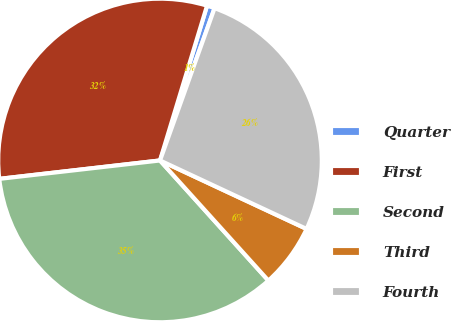Convert chart to OTSL. <chart><loc_0><loc_0><loc_500><loc_500><pie_chart><fcel>Quarter<fcel>First<fcel>Second<fcel>Third<fcel>Fourth<nl><fcel>0.78%<fcel>31.51%<fcel>34.87%<fcel>6.36%<fcel>26.48%<nl></chart> 